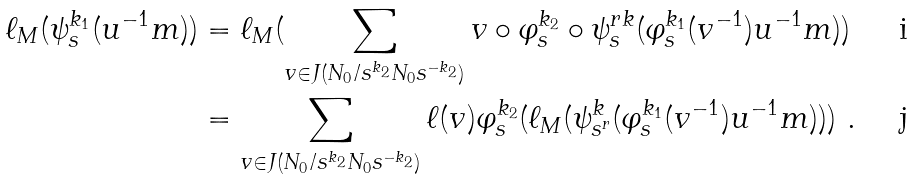<formula> <loc_0><loc_0><loc_500><loc_500>\ell _ { M } ( \psi _ { s } ^ { k _ { 1 } } ( u ^ { - 1 } m ) ) & = \ell _ { M } ( \sum _ { v \in J ( N _ { 0 } / s ^ { k _ { 2 } } N _ { 0 } s ^ { - k _ { 2 } } ) } v \circ \varphi _ { s } ^ { k _ { 2 } } \circ \psi _ { s } ^ { r k } ( \varphi _ { s } ^ { k _ { 1 } } ( v ^ { - 1 } ) u ^ { - 1 } m ) ) \\ & = \sum _ { v \in J ( N _ { 0 } / s ^ { k _ { 2 } } N _ { 0 } s ^ { - k _ { 2 } } ) } \ell ( v ) \varphi _ { s } ^ { k _ { 2 } } ( \ell _ { M } ( \psi _ { s ^ { r } } ^ { k } ( \varphi _ { s } ^ { k _ { 1 } } ( v ^ { - 1 } ) u ^ { - 1 } m ) ) ) \ .</formula> 